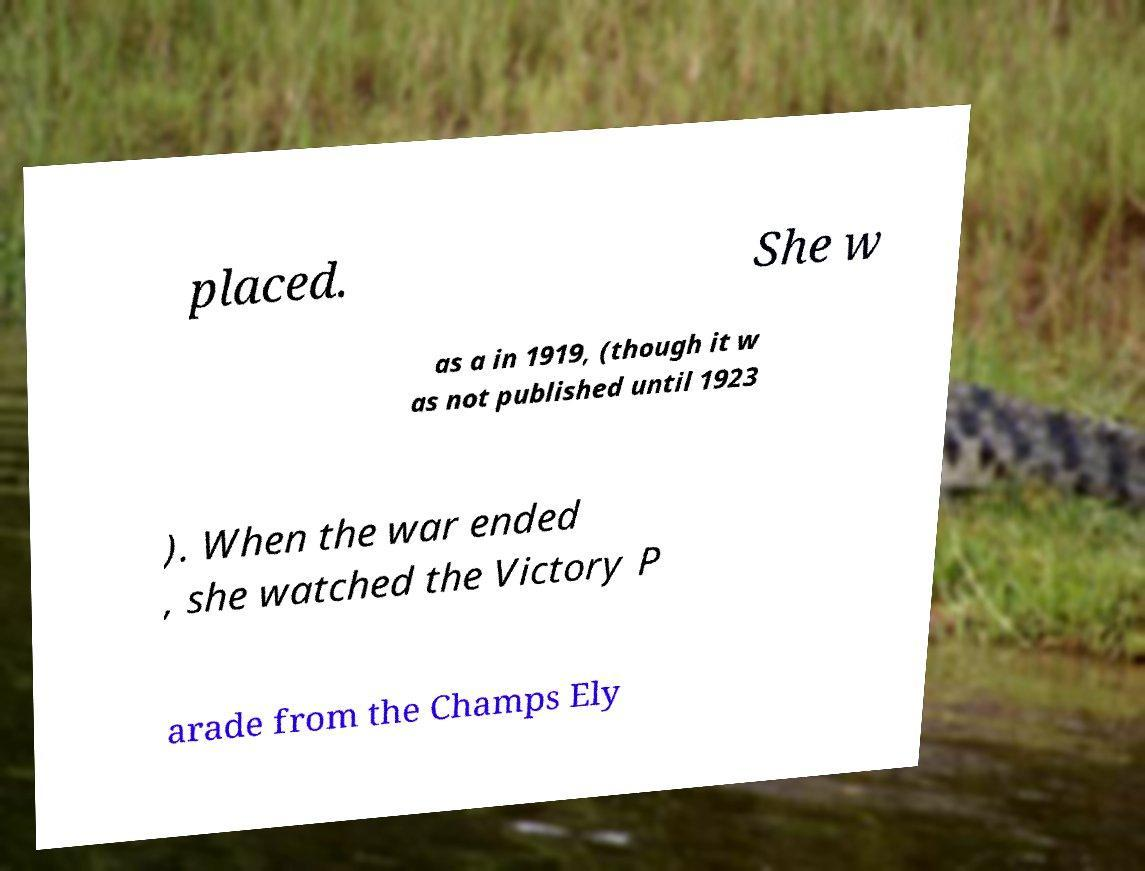What messages or text are displayed in this image? I need them in a readable, typed format. placed. She w as a in 1919, (though it w as not published until 1923 ). When the war ended , she watched the Victory P arade from the Champs Ely 